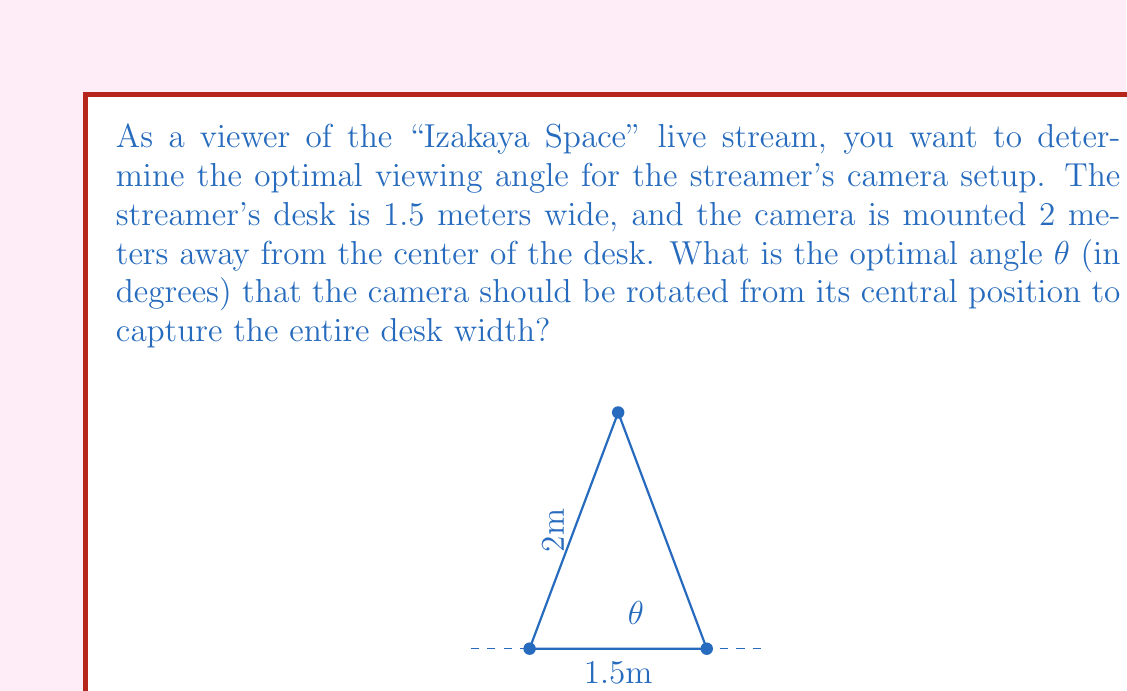Can you answer this question? Let's approach this step-by-step:

1) We can visualize this problem as a right triangle, where:
   - The base is half the desk width (as we're considering the angle from the center)
   - The height is the distance from the camera to the desk
   - The hypotenuse is the line of sight from the camera to the edge of the desk

2) We need to find the angle θ between the central line and the line of sight to the desk edge.

3) We can use the tangent function to find this angle:

   $$\tan(\theta) = \frac{\text{opposite}}{\text{adjacent}} = \frac{\text{half desk width}}{\text{camera distance}}$$

4) Half the desk width is 1.5 m ÷ 2 = 0.75 m

5) Substituting the values:

   $$\tan(\theta) = \frac{0.75}{2}$$

6) To find θ, we need to use the inverse tangent (arctangent) function:

   $$\theta = \arctan(\frac{0.75}{2})$$

7) Using a calculator or computer:

   $$\theta \approx 0.3587 \text{ radians}$$

8) Convert to degrees:

   $$\theta \approx 0.3587 \times \frac{180}{\pi} \approx 20.556°$$

9) Since this is the angle to one edge, we need to double it to get the full viewing angle:

   $$\text{Full viewing angle} = 2\theta \approx 41.112°$$

10) Rounding to the nearest tenth of a degree:

    $$\text{Full viewing angle} \approx 41.1°$$
Answer: 41.1° 